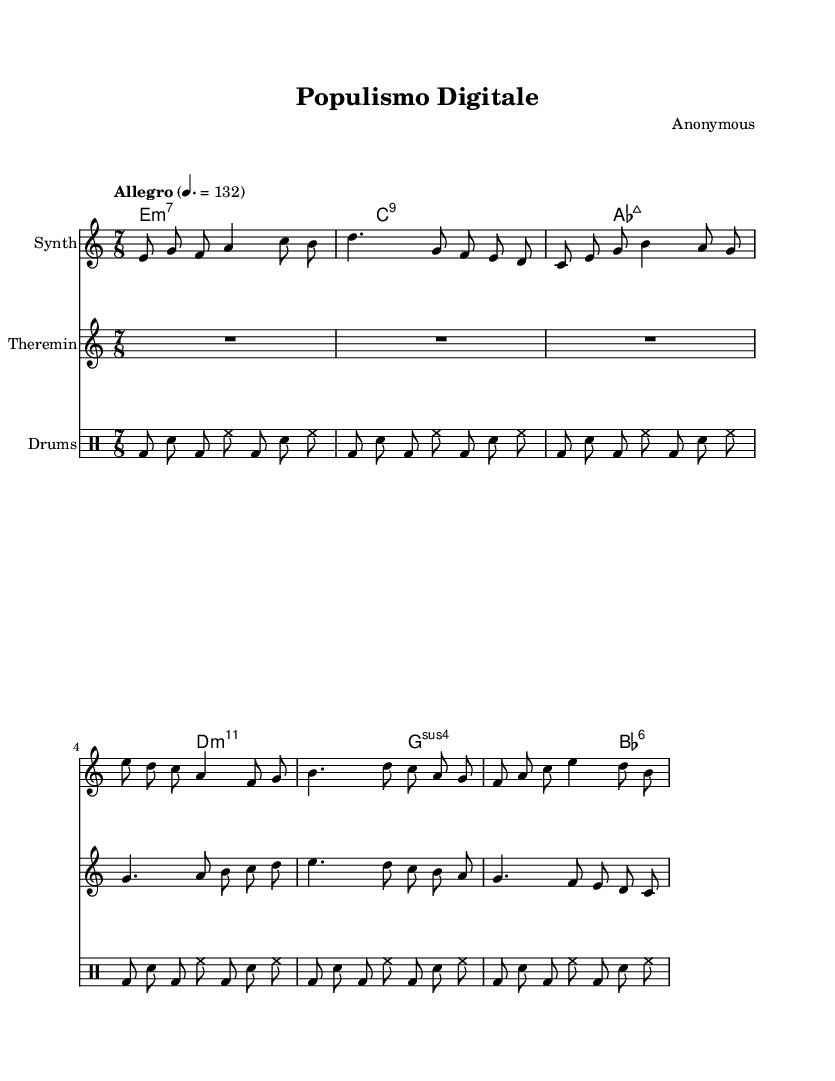What is the time signature of this music? The time signature is indicated at the beginning of the score as 7/8, which shows that there are seven beats in each measure, and the eighth note gets one beat.
Answer: 7/8 What is the tempo marking for this piece? The tempo marking at the start indicates "Allegro," with a metronome marking of 132 beats per minute, suggesting a fast tempo.
Answer: Allegro How many measures are present in the drum part? By counting the groups of notes shown in the drum part, there are six measures indicated. Each measure contains a distinct pattern.
Answer: Six Which instrument features a repeated note pattern? The synthesizer part includes sections with repeated note patterns, notably using the note C and others in a consistent rhythm.
Answer: Synthesizer What chord is indicated at the beginning of this piece? The first chord symbol presented is "e:m7," suggesting a minor seventh chord based on E.
Answer: e:m7 What changes occur in the theremin part compared to the synthesizer? The theremin part includes rests and longer note durations compared to the synthesizer, showcasing a more fluid and legato style.
Answer: Rests 